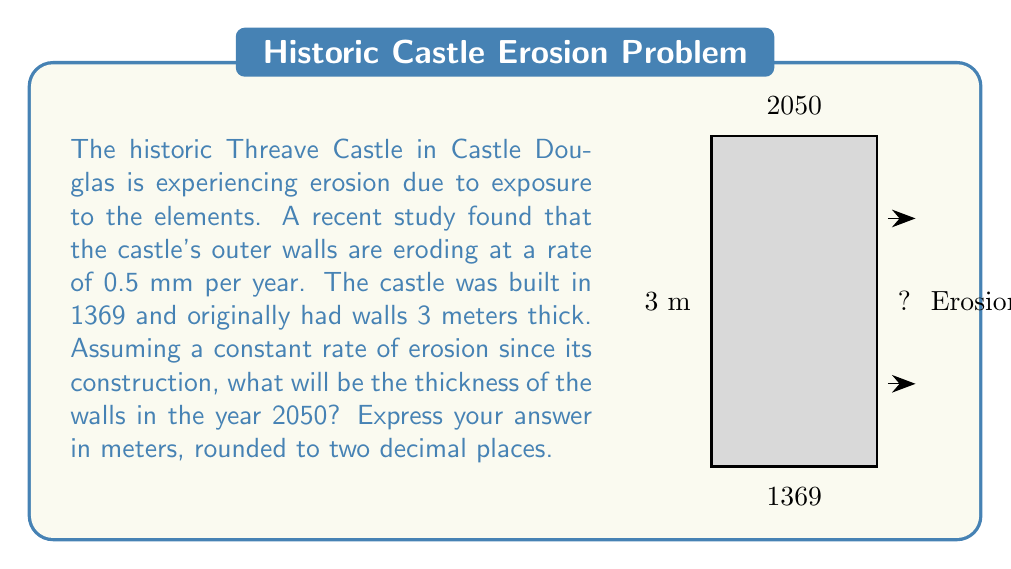Show me your answer to this math problem. To solve this problem, we'll follow these steps:

1) First, calculate the number of years between the castle's construction and 2050:
   $$\text{Years of erosion} = 2050 - 1369 = 681 \text{ years}$$

2) Convert the erosion rate from mm/year to m/year:
   $$\text{Erosion rate} = 0.5 \text{ mm/year} = 0.0005 \text{ m/year}$$

3) Calculate the total erosion over 681 years:
   $$\text{Total erosion} = 681 \text{ years} \times 0.0005 \text{ m/year} = 0.3405 \text{ m}$$

4) Subtract the total erosion from the original wall thickness:
   $$\text{Wall thickness in 2050} = 3 \text{ m} - 0.3405 \text{ m} = 2.6595 \text{ m}$$

5) Round the result to two decimal places:
   $$2.6595 \text{ m} \approx 2.66 \text{ m}$$

Therefore, the wall thickness in 2050 will be approximately 2.66 meters.
Answer: 2.66 m 